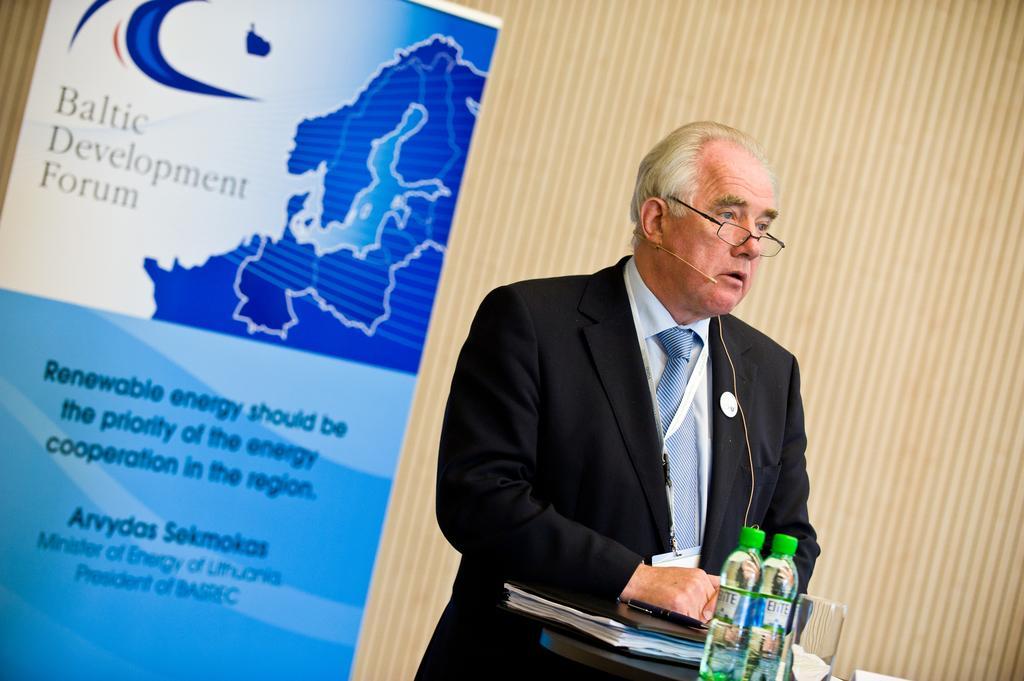Could you give a brief overview of what you see in this image? On the right side of the image there is a podium with bottles, glass and file with papers in it. Behind the podium there is a man with mic and a tag around his neck. Behind him there is a banner with images and text on it. 